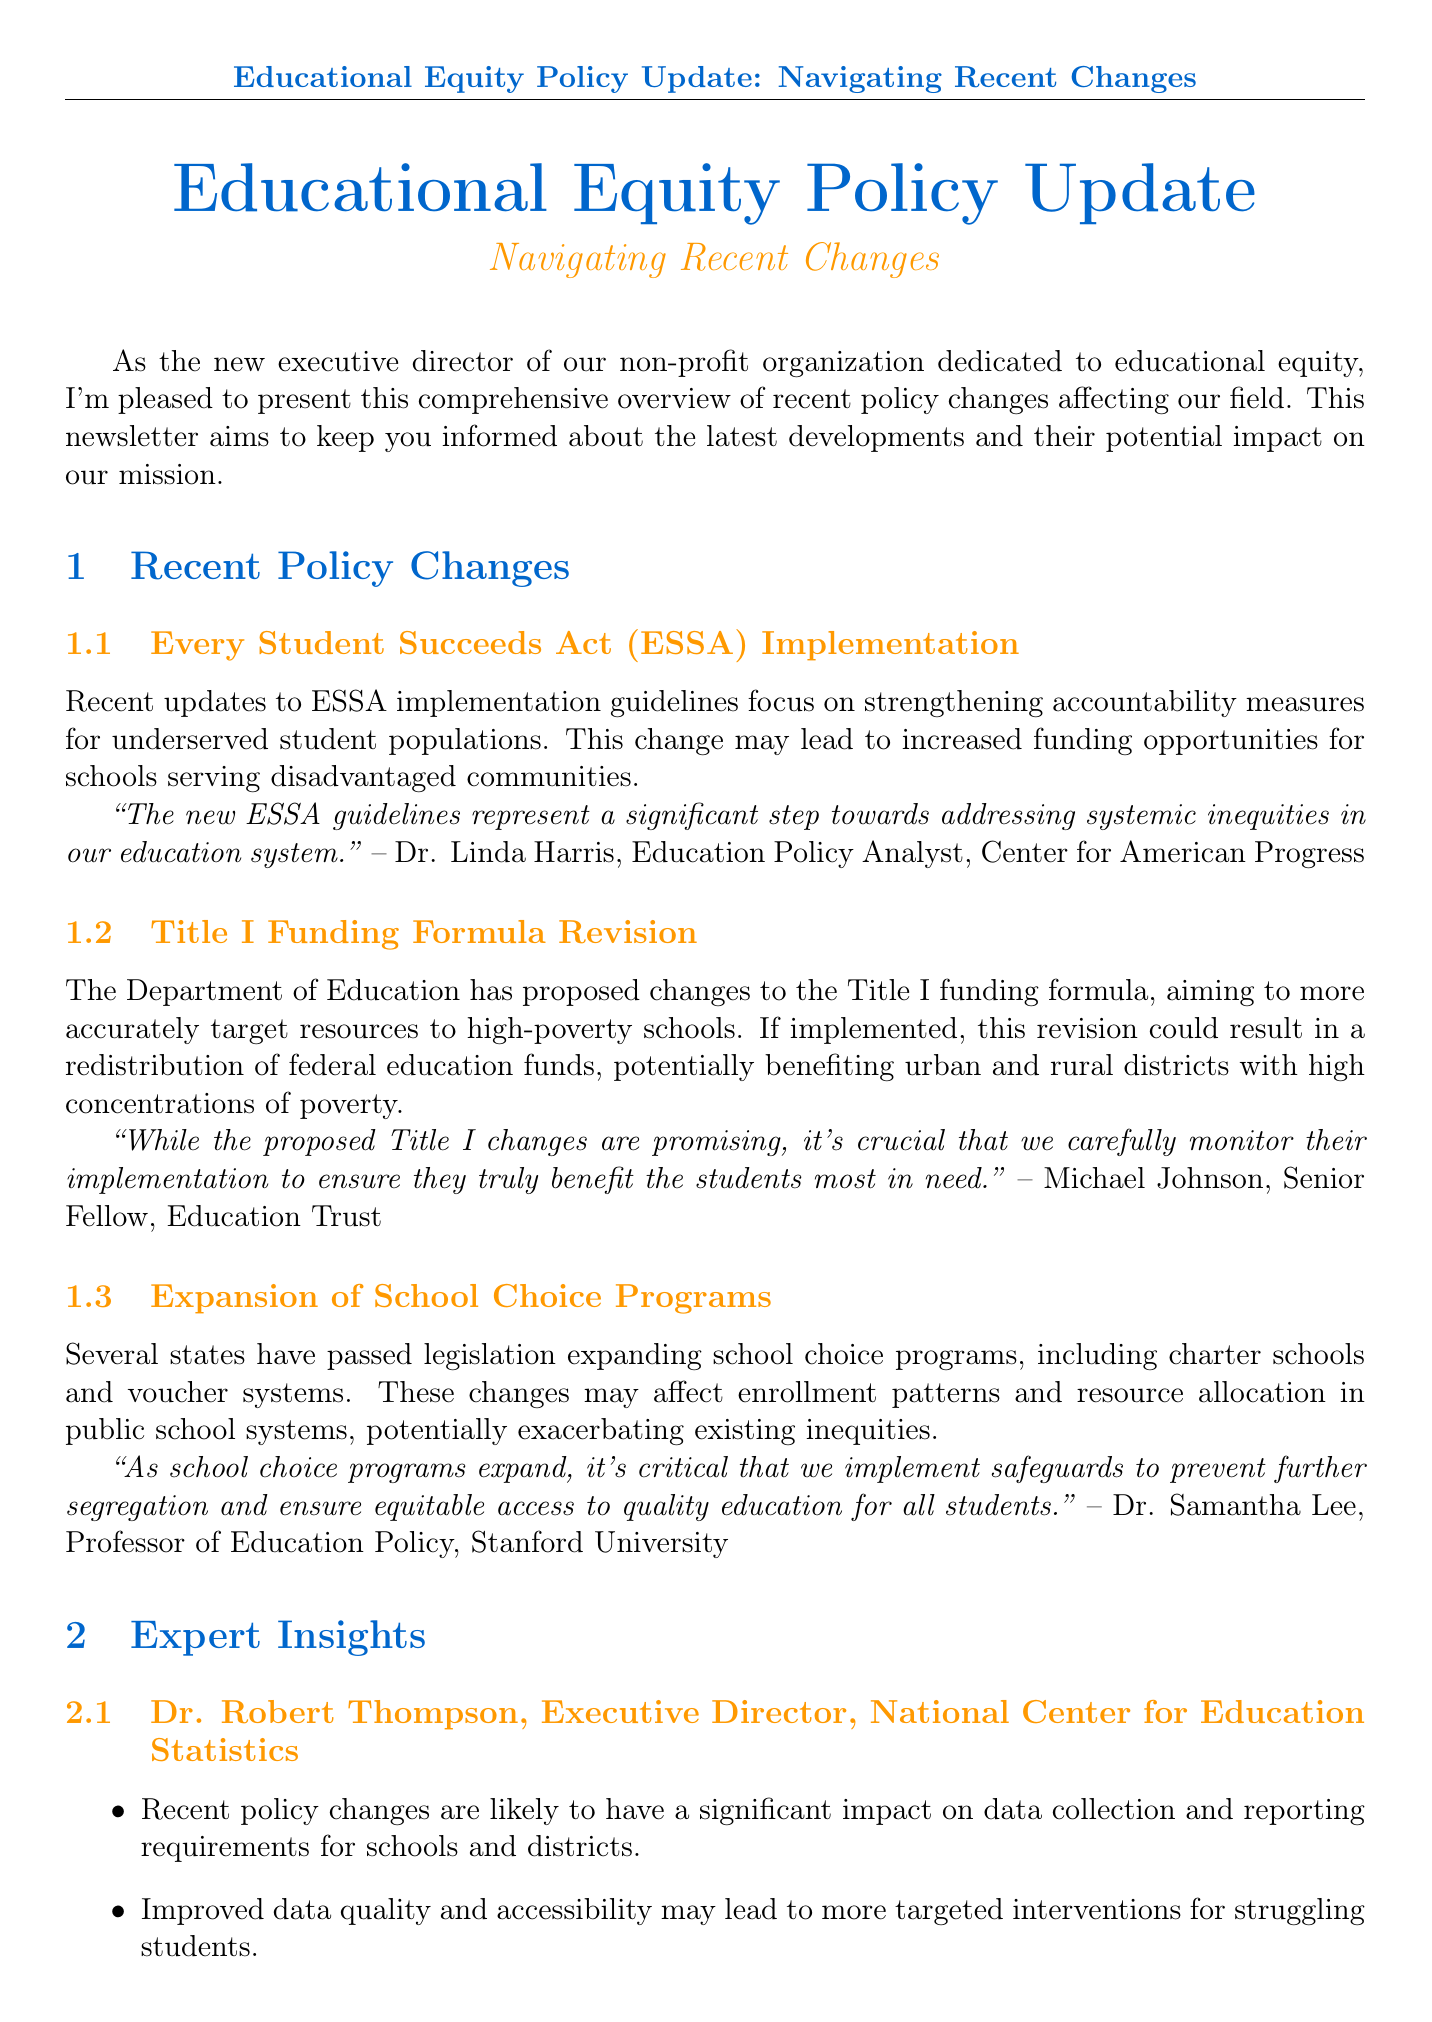What is the title of the newsletter? The title of the newsletter is presented at the beginning and is "Educational Equity Policy Update: Navigating Recent Changes."
Answer: Educational Equity Policy Update: Navigating Recent Changes Who is quoted about the ESSA guidelines? Dr. Linda Harris is the expert quoted regarding the ESSA guidelines in the document.
Answer: Dr. Linda Harris What is the projected increase in graduation rates for English Language Learners? The document includes a specific data point indicating the expected increase in graduation rates for English Language Learners is 15%.
Answer: 15% Which states are projected to see an increase in Title I funding? The infographic section states that 35 states are projected to see an increase in Title I funding.
Answer: 35 states What is the position of Maria Gonzalez? The document specifies that Maria Gonzalez holds the position of Chief Equity Officer.
Answer: Chief Equity Officer What is the focus of the upcoming webinar series mentioned in the conclusion? The conclusion states that the webinar series will focus on "Implementing New Policies for Student Success."
Answer: Implementing New Policies for Student Success What is a potential impact of the expansion of school choice programs according to the document? The document indicates that the expansion of school choice programs may affect enrollment patterns and resource allocation in public school systems.
Answer: Affect enrollment patterns and resource allocation How many states are expected to experience a decrease in Title I funding? The document states clearly that 12 states are expected to experience a decrease in Title I funding.
Answer: 12 states 